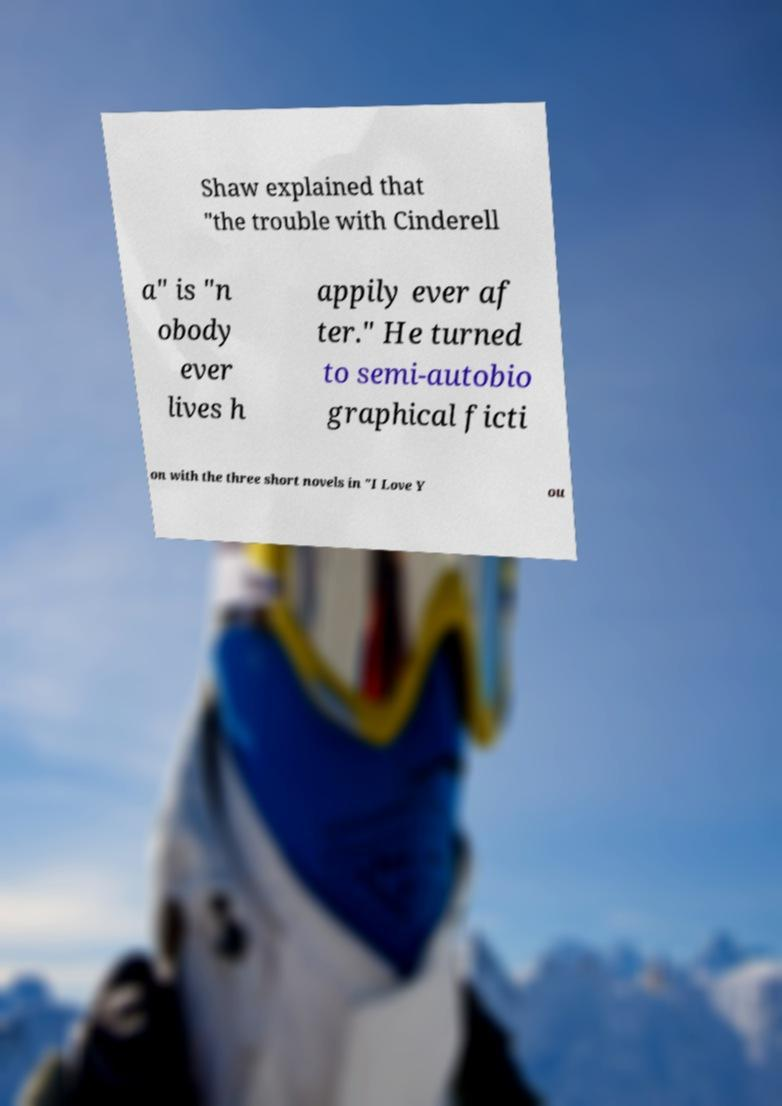Please identify and transcribe the text found in this image. Shaw explained that "the trouble with Cinderell a" is "n obody ever lives h appily ever af ter." He turned to semi-autobio graphical ficti on with the three short novels in "I Love Y ou 